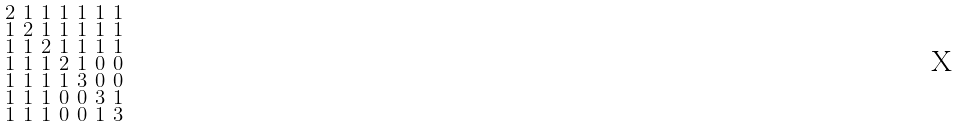Convert formula to latex. <formula><loc_0><loc_0><loc_500><loc_500>\begin{smallmatrix} 2 & 1 & 1 & 1 & 1 & 1 & 1 \\ 1 & 2 & 1 & 1 & 1 & 1 & 1 \\ 1 & 1 & 2 & 1 & 1 & 1 & 1 \\ 1 & 1 & 1 & 2 & 1 & 0 & 0 \\ 1 & 1 & 1 & 1 & 3 & 0 & 0 \\ 1 & 1 & 1 & 0 & 0 & 3 & 1 \\ 1 & 1 & 1 & 0 & 0 & 1 & 3 \end{smallmatrix}</formula> 